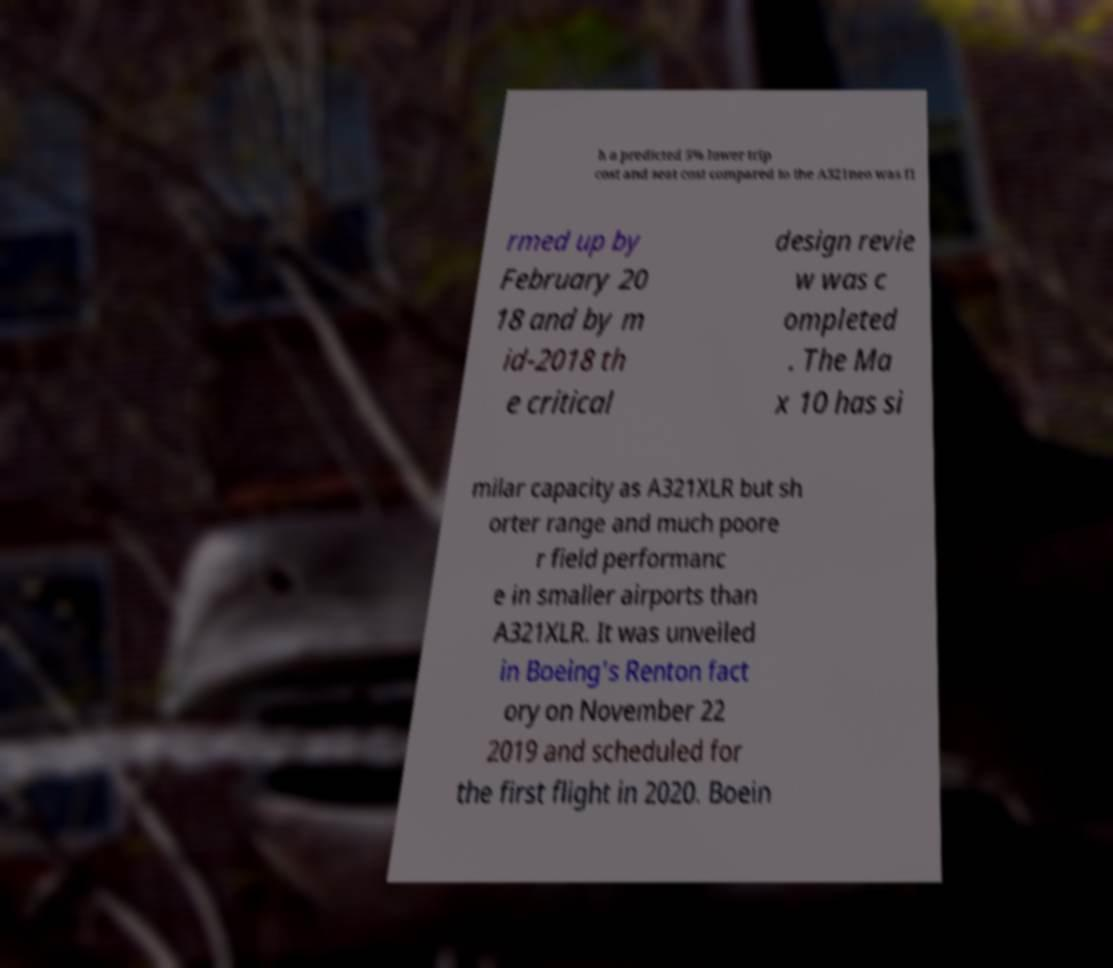I need the written content from this picture converted into text. Can you do that? h a predicted 5% lower trip cost and seat cost compared to the A321neo was fi rmed up by February 20 18 and by m id-2018 th e critical design revie w was c ompleted . The Ma x 10 has si milar capacity as A321XLR but sh orter range and much poore r field performanc e in smaller airports than A321XLR. It was unveiled in Boeing's Renton fact ory on November 22 2019 and scheduled for the first flight in 2020. Boein 